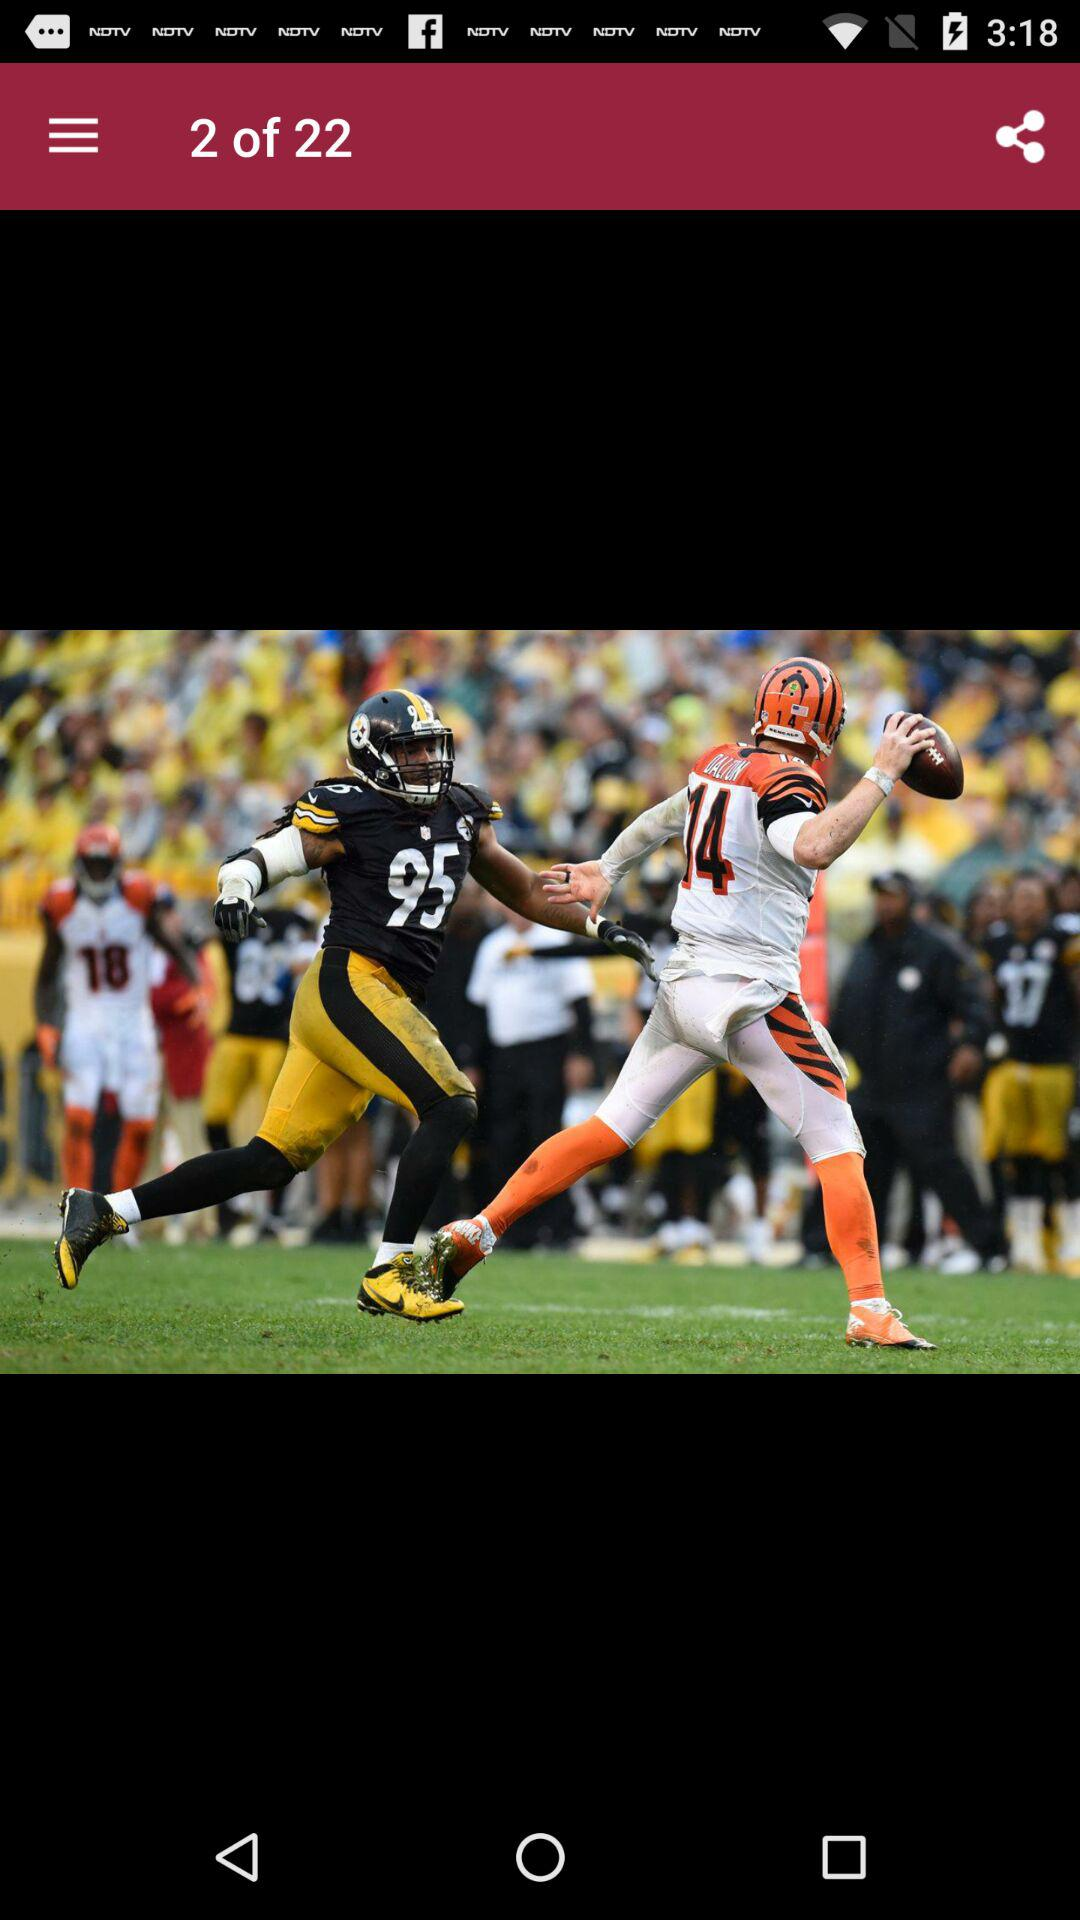How many images in total are there? There are 22 images in total. 